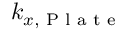<formula> <loc_0><loc_0><loc_500><loc_500>k _ { x , P l a t e }</formula> 